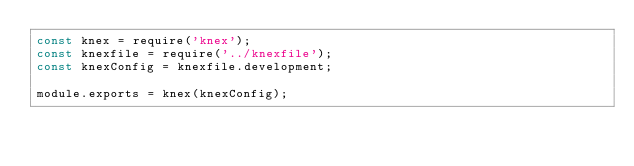<code> <loc_0><loc_0><loc_500><loc_500><_JavaScript_>const knex = require('knex');
const knexfile = require('../knexfile');
const knexConfig = knexfile.development;

module.exports = knex(knexConfig);</code> 